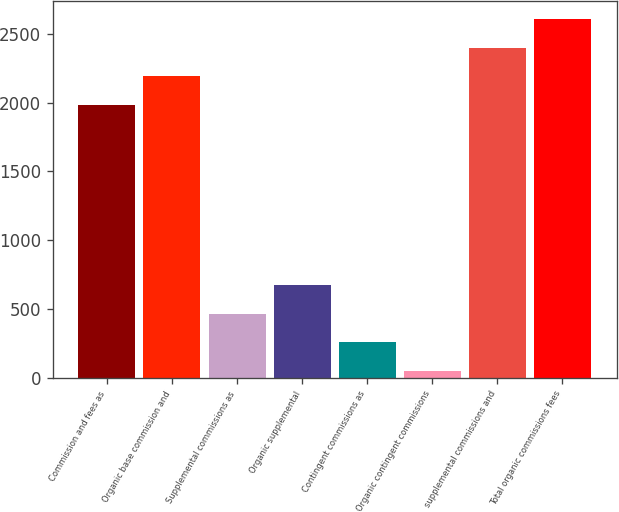<chart> <loc_0><loc_0><loc_500><loc_500><bar_chart><fcel>Commission and fees as<fcel>Organic base commission and<fcel>Supplemental commissions as<fcel>Organic supplemental<fcel>Contingent commissions as<fcel>Organic contingent commissions<fcel>supplemental commissions and<fcel>Total organic commissions fees<nl><fcel>1985.6<fcel>2192.11<fcel>464.92<fcel>671.43<fcel>258.41<fcel>51.9<fcel>2398.62<fcel>2605.13<nl></chart> 